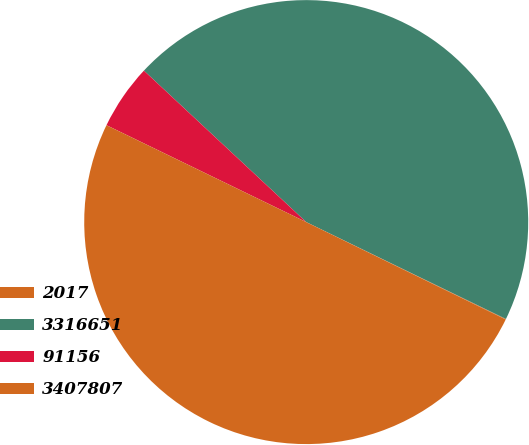Convert chart to OTSL. <chart><loc_0><loc_0><loc_500><loc_500><pie_chart><fcel>2017<fcel>3316651<fcel>91156<fcel>3407807<nl><fcel>0.04%<fcel>45.24%<fcel>4.76%<fcel>49.96%<nl></chart> 